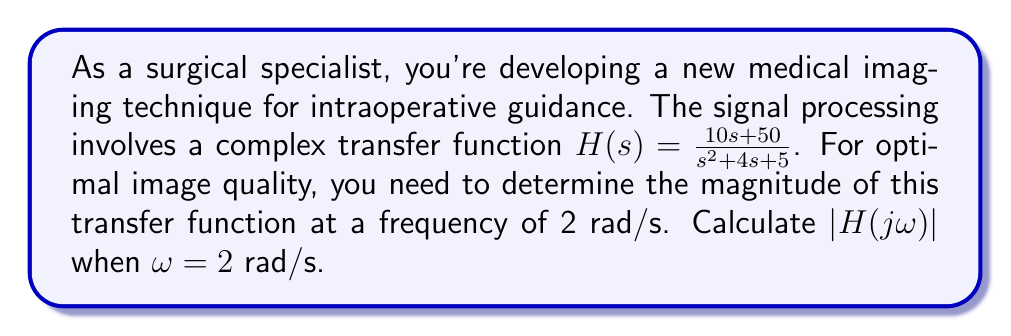Show me your answer to this math problem. To solve this problem, we'll follow these steps:

1) First, we substitute $s = j\omega$ into the transfer function:

   $H(j\omega) = \frac{10j\omega + 50}{(j\omega)^2 + 4j\omega + 5}$

2) Now, we substitute $\omega = 2$:

   $H(j2) = \frac{10j(2) + 50}{(j2)^2 + 4j(2) + 5} = \frac{20j + 50}{-4 + 8j + 5} = \frac{20j + 50}{1 + 8j}$

3) To find the magnitude, we use the formula:

   $|H(j\omega)| = \sqrt{\frac{(\text{Re}(numerator))^2 + (\text{Im}(numerator))^2}{(\text{Re}(denominator))^2 + (\text{Im}(denominator))^2}}$

4) Identifying the real and imaginary parts:

   Numerator: $\text{Re} = 50$, $\text{Im} = 20$
   Denominator: $\text{Re} = 1$, $\text{Im} = 8$

5) Substituting into the formula:

   $|H(j2)| = \sqrt{\frac{50^2 + 20^2}{1^2 + 8^2}} = \sqrt{\frac{2900}{65}}$

6) Simplifying:

   $|H(j2)| = \sqrt{\frac{2900}{65}} \approx 6.67$
Answer: $|H(j2)| = \sqrt{\frac{2900}{65}} \approx 6.67$ 